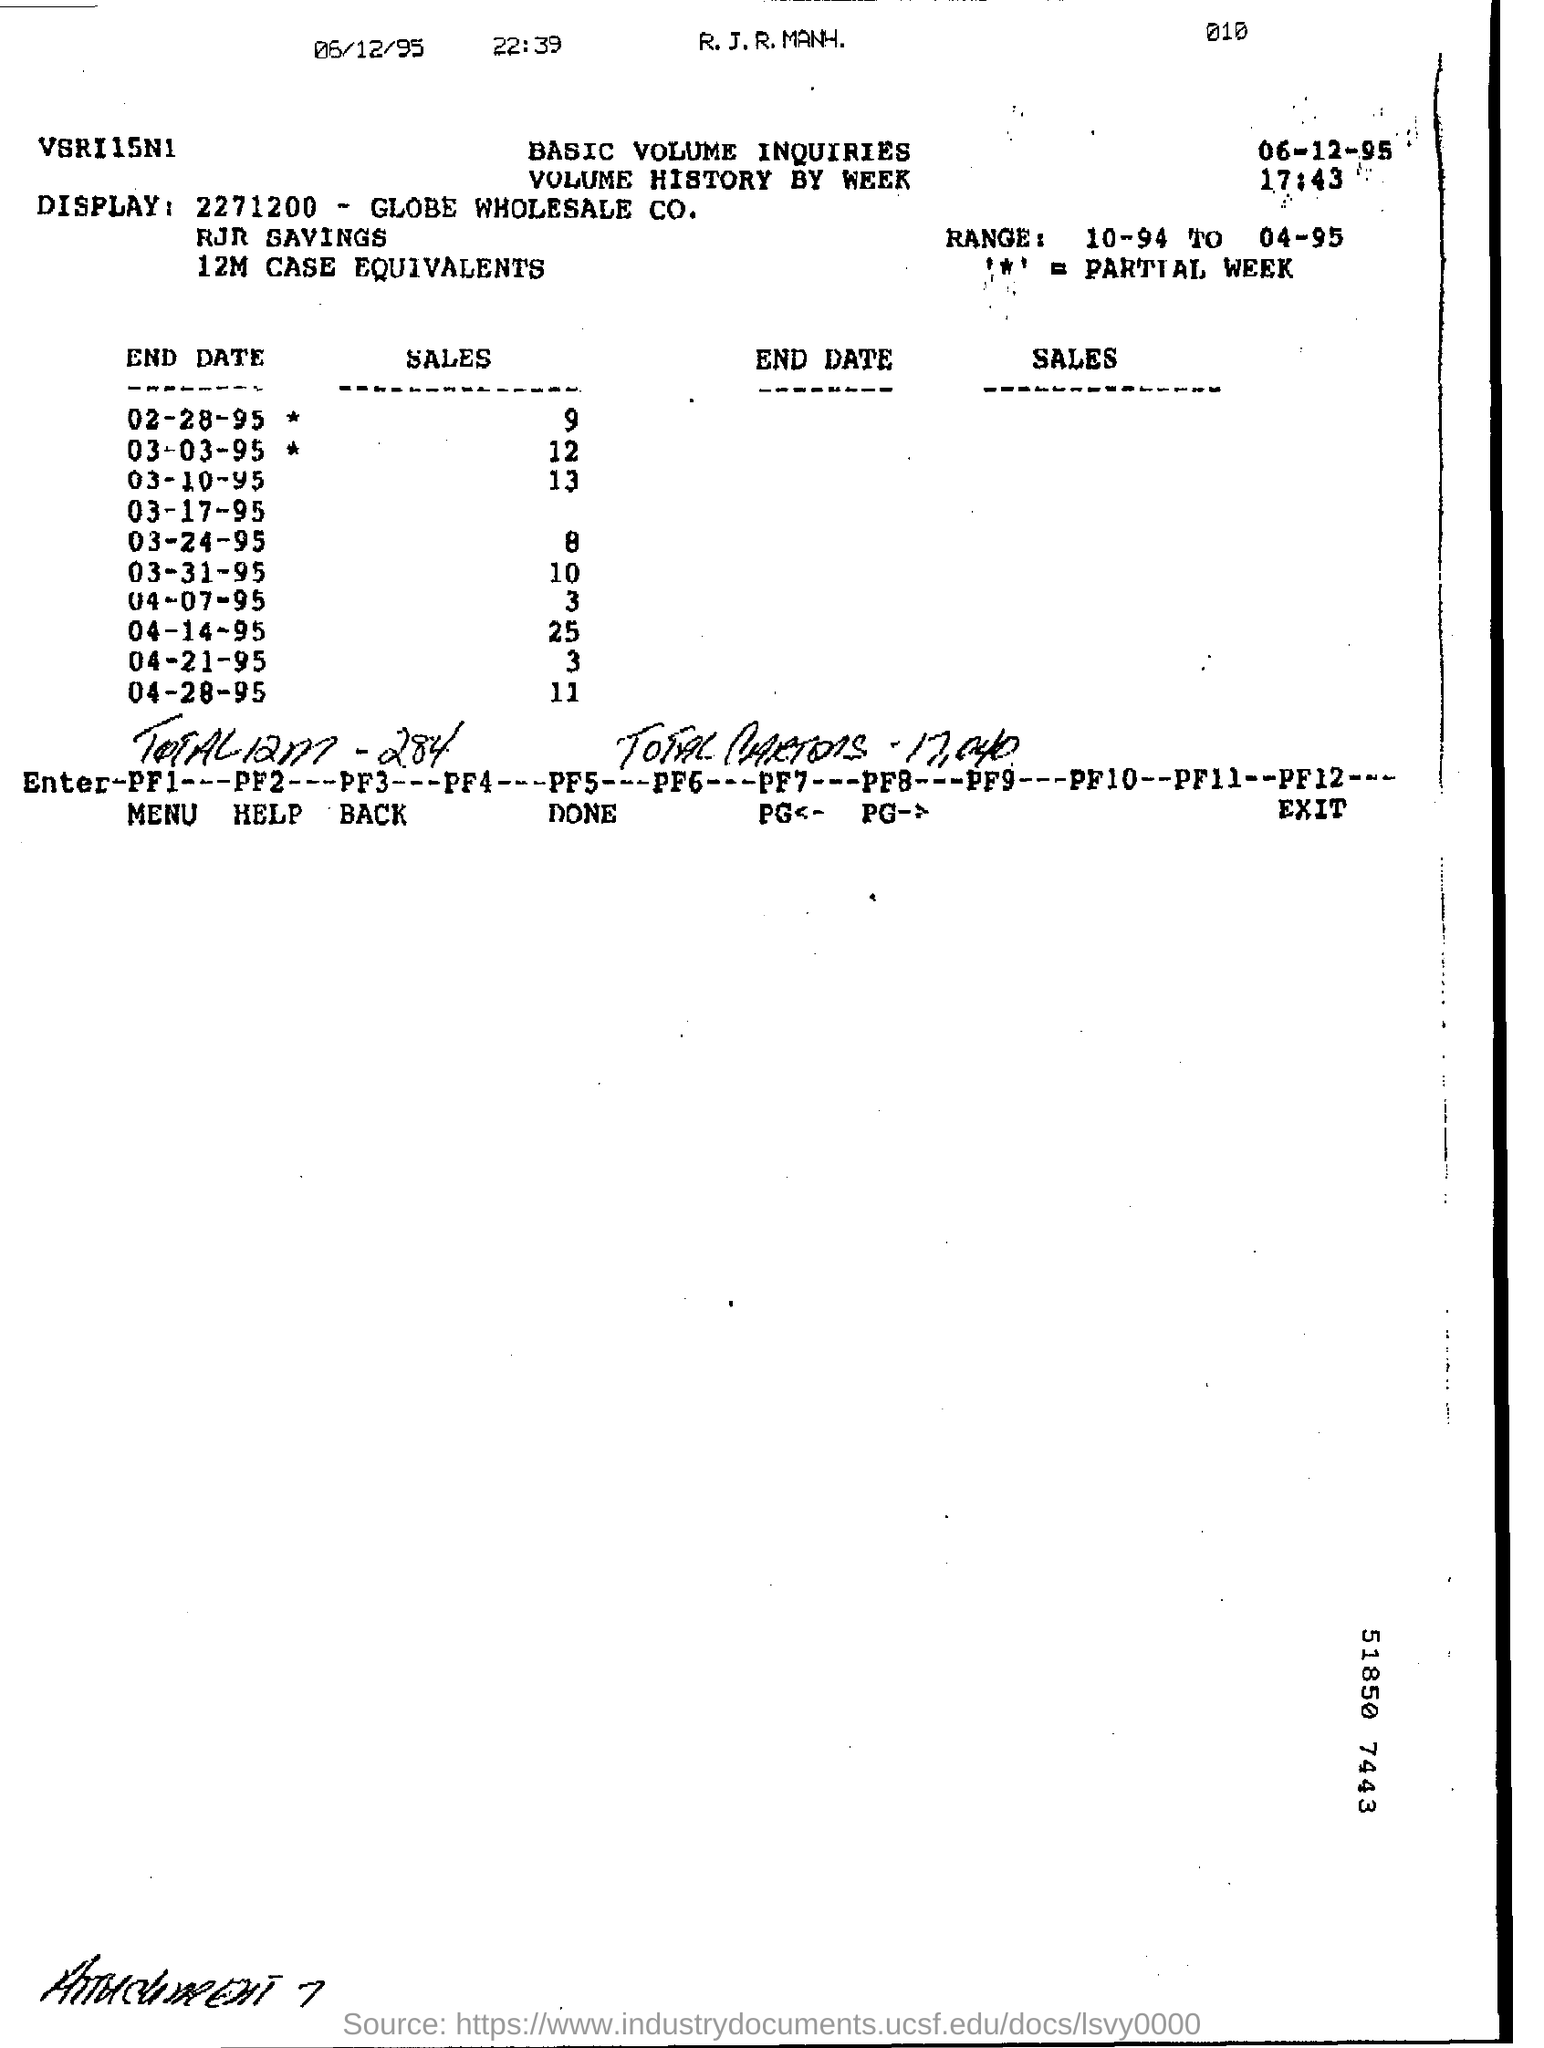Specify some key components in this picture. What are the sales by the end of March 3, 1995? Specifically, by 12:00 PM. The range mentioned is from 10-94 to 04-95. The largest number of sales was made on April 14, 1995. 